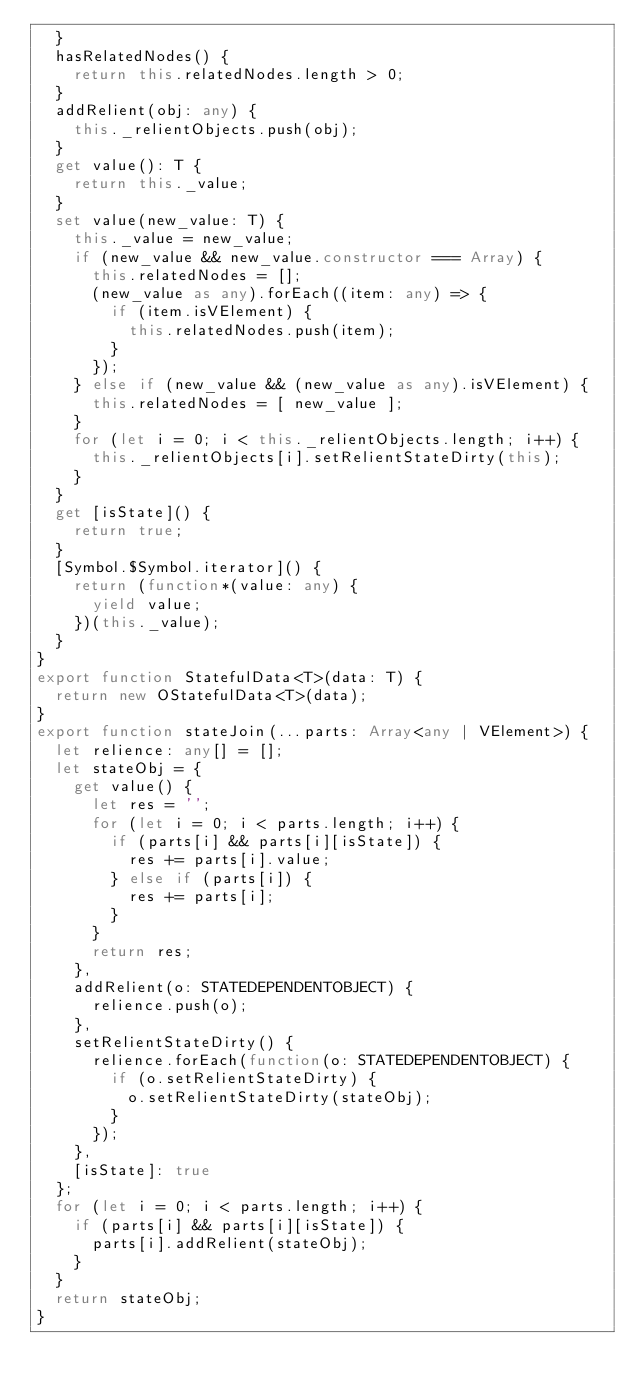Convert code to text. <code><loc_0><loc_0><loc_500><loc_500><_TypeScript_>	}
	hasRelatedNodes() {
		return this.relatedNodes.length > 0;
	}
	addRelient(obj: any) {
		this._relientObjects.push(obj);
	}
	get value(): T {
		return this._value;
	}
	set value(new_value: T) {
		this._value = new_value;
		if (new_value && new_value.constructor === Array) {
			this.relatedNodes = [];
			(new_value as any).forEach((item: any) => {
				if (item.isVElement) {
					this.relatedNodes.push(item);
				}
			});
		} else if (new_value && (new_value as any).isVElement) {
			this.relatedNodes = [ new_value ];
		}
		for (let i = 0; i < this._relientObjects.length; i++) {
			this._relientObjects[i].setRelientStateDirty(this);
		}
	}
	get [isState]() {
		return true;
	}
	[Symbol.$Symbol.iterator]() {
		return (function*(value: any) {
			yield value;
		})(this._value);
	}
}
export function StatefulData<T>(data: T) {
	return new OStatefulData<T>(data);
}
export function stateJoin(...parts: Array<any | VElement>) {
	let relience: any[] = [];
	let stateObj = {
		get value() {
			let res = '';
			for (let i = 0; i < parts.length; i++) {
				if (parts[i] && parts[i][isState]) {
					res += parts[i].value;
				} else if (parts[i]) {
					res += parts[i];
				}
			}
			return res;
		},
		addRelient(o: STATEDEPENDENTOBJECT) {
			relience.push(o);
		},
		setRelientStateDirty() {
			relience.forEach(function(o: STATEDEPENDENTOBJECT) {
				if (o.setRelientStateDirty) {
					o.setRelientStateDirty(stateObj);
				}
			});
		},
		[isState]: true
	};
	for (let i = 0; i < parts.length; i++) {
		if (parts[i] && parts[i][isState]) {
			parts[i].addRelient(stateObj);
		}
	}
	return stateObj;
}
</code> 